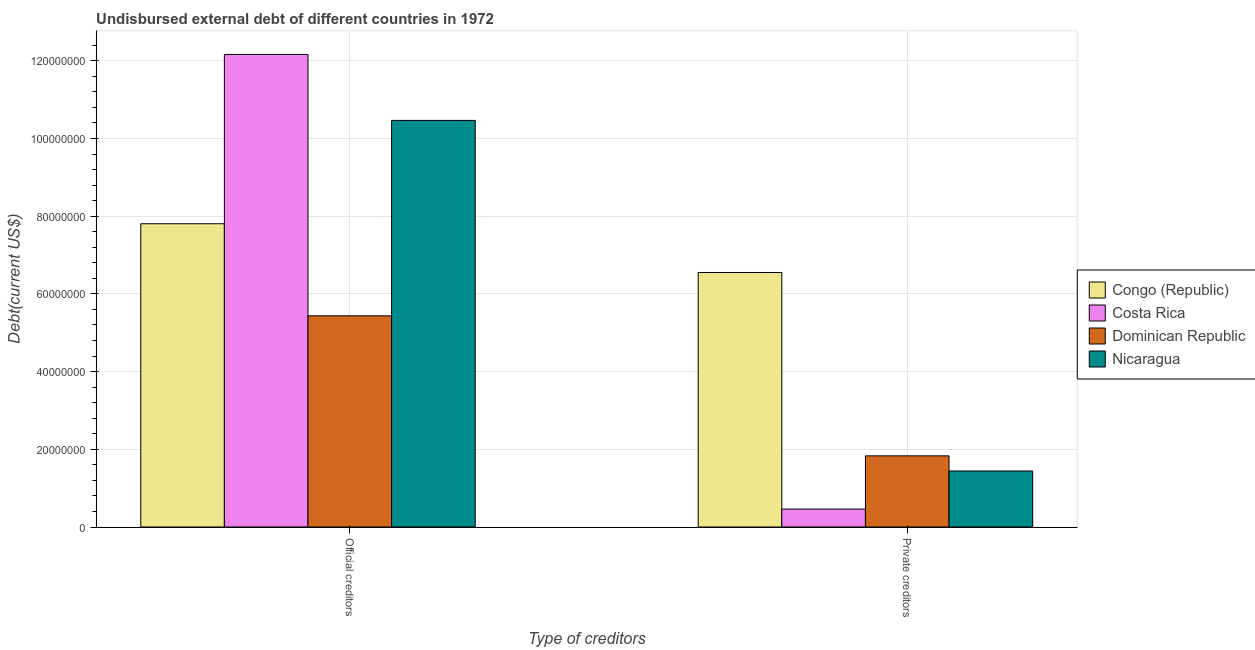How many different coloured bars are there?
Give a very brief answer. 4. How many groups of bars are there?
Make the answer very short. 2. How many bars are there on the 1st tick from the right?
Your answer should be compact. 4. What is the label of the 1st group of bars from the left?
Offer a very short reply. Official creditors. What is the undisbursed external debt of official creditors in Dominican Republic?
Offer a terse response. 5.44e+07. Across all countries, what is the maximum undisbursed external debt of official creditors?
Give a very brief answer. 1.22e+08. Across all countries, what is the minimum undisbursed external debt of private creditors?
Ensure brevity in your answer.  4.62e+06. What is the total undisbursed external debt of official creditors in the graph?
Offer a very short reply. 3.59e+08. What is the difference between the undisbursed external debt of private creditors in Nicaragua and that in Costa Rica?
Provide a succinct answer. 9.80e+06. What is the difference between the undisbursed external debt of official creditors in Costa Rica and the undisbursed external debt of private creditors in Congo (Republic)?
Your response must be concise. 5.61e+07. What is the average undisbursed external debt of official creditors per country?
Ensure brevity in your answer.  8.97e+07. What is the difference between the undisbursed external debt of official creditors and undisbursed external debt of private creditors in Costa Rica?
Your answer should be compact. 1.17e+08. In how many countries, is the undisbursed external debt of official creditors greater than 88000000 US$?
Provide a short and direct response. 2. What is the ratio of the undisbursed external debt of official creditors in Costa Rica to that in Nicaragua?
Provide a short and direct response. 1.16. What does the 1st bar from the left in Official creditors represents?
Make the answer very short. Congo (Republic). What does the 3rd bar from the right in Private creditors represents?
Your answer should be compact. Costa Rica. How many bars are there?
Your response must be concise. 8. Are all the bars in the graph horizontal?
Make the answer very short. No. How many countries are there in the graph?
Give a very brief answer. 4. Does the graph contain any zero values?
Your answer should be very brief. No. Does the graph contain grids?
Provide a succinct answer. Yes. How many legend labels are there?
Give a very brief answer. 4. What is the title of the graph?
Your response must be concise. Undisbursed external debt of different countries in 1972. Does "Greece" appear as one of the legend labels in the graph?
Make the answer very short. No. What is the label or title of the X-axis?
Offer a very short reply. Type of creditors. What is the label or title of the Y-axis?
Give a very brief answer. Debt(current US$). What is the Debt(current US$) of Congo (Republic) in Official creditors?
Provide a short and direct response. 7.81e+07. What is the Debt(current US$) in Costa Rica in Official creditors?
Make the answer very short. 1.22e+08. What is the Debt(current US$) of Dominican Republic in Official creditors?
Provide a succinct answer. 5.44e+07. What is the Debt(current US$) in Nicaragua in Official creditors?
Your response must be concise. 1.05e+08. What is the Debt(current US$) in Congo (Republic) in Private creditors?
Make the answer very short. 6.55e+07. What is the Debt(current US$) of Costa Rica in Private creditors?
Keep it short and to the point. 4.62e+06. What is the Debt(current US$) of Dominican Republic in Private creditors?
Make the answer very short. 1.83e+07. What is the Debt(current US$) in Nicaragua in Private creditors?
Give a very brief answer. 1.44e+07. Across all Type of creditors, what is the maximum Debt(current US$) in Congo (Republic)?
Provide a short and direct response. 7.81e+07. Across all Type of creditors, what is the maximum Debt(current US$) in Costa Rica?
Ensure brevity in your answer.  1.22e+08. Across all Type of creditors, what is the maximum Debt(current US$) in Dominican Republic?
Offer a very short reply. 5.44e+07. Across all Type of creditors, what is the maximum Debt(current US$) of Nicaragua?
Your answer should be very brief. 1.05e+08. Across all Type of creditors, what is the minimum Debt(current US$) of Congo (Republic)?
Give a very brief answer. 6.55e+07. Across all Type of creditors, what is the minimum Debt(current US$) in Costa Rica?
Ensure brevity in your answer.  4.62e+06. Across all Type of creditors, what is the minimum Debt(current US$) in Dominican Republic?
Offer a terse response. 1.83e+07. Across all Type of creditors, what is the minimum Debt(current US$) of Nicaragua?
Give a very brief answer. 1.44e+07. What is the total Debt(current US$) in Congo (Republic) in the graph?
Offer a very short reply. 1.44e+08. What is the total Debt(current US$) in Costa Rica in the graph?
Offer a very short reply. 1.26e+08. What is the total Debt(current US$) of Dominican Republic in the graph?
Your answer should be compact. 7.27e+07. What is the total Debt(current US$) of Nicaragua in the graph?
Offer a terse response. 1.19e+08. What is the difference between the Debt(current US$) of Congo (Republic) in Official creditors and that in Private creditors?
Ensure brevity in your answer.  1.25e+07. What is the difference between the Debt(current US$) in Costa Rica in Official creditors and that in Private creditors?
Ensure brevity in your answer.  1.17e+08. What is the difference between the Debt(current US$) in Dominican Republic in Official creditors and that in Private creditors?
Make the answer very short. 3.60e+07. What is the difference between the Debt(current US$) in Nicaragua in Official creditors and that in Private creditors?
Your answer should be very brief. 9.02e+07. What is the difference between the Debt(current US$) in Congo (Republic) in Official creditors and the Debt(current US$) in Costa Rica in Private creditors?
Offer a terse response. 7.34e+07. What is the difference between the Debt(current US$) in Congo (Republic) in Official creditors and the Debt(current US$) in Dominican Republic in Private creditors?
Ensure brevity in your answer.  5.97e+07. What is the difference between the Debt(current US$) of Congo (Republic) in Official creditors and the Debt(current US$) of Nicaragua in Private creditors?
Your answer should be compact. 6.36e+07. What is the difference between the Debt(current US$) of Costa Rica in Official creditors and the Debt(current US$) of Dominican Republic in Private creditors?
Make the answer very short. 1.03e+08. What is the difference between the Debt(current US$) of Costa Rica in Official creditors and the Debt(current US$) of Nicaragua in Private creditors?
Your answer should be very brief. 1.07e+08. What is the difference between the Debt(current US$) of Dominican Republic in Official creditors and the Debt(current US$) of Nicaragua in Private creditors?
Offer a very short reply. 3.99e+07. What is the average Debt(current US$) of Congo (Republic) per Type of creditors?
Your answer should be compact. 7.18e+07. What is the average Debt(current US$) of Costa Rica per Type of creditors?
Keep it short and to the point. 6.31e+07. What is the average Debt(current US$) in Dominican Republic per Type of creditors?
Offer a very short reply. 3.63e+07. What is the average Debt(current US$) of Nicaragua per Type of creditors?
Give a very brief answer. 5.95e+07. What is the difference between the Debt(current US$) of Congo (Republic) and Debt(current US$) of Costa Rica in Official creditors?
Your response must be concise. -4.36e+07. What is the difference between the Debt(current US$) of Congo (Republic) and Debt(current US$) of Dominican Republic in Official creditors?
Ensure brevity in your answer.  2.37e+07. What is the difference between the Debt(current US$) in Congo (Republic) and Debt(current US$) in Nicaragua in Official creditors?
Keep it short and to the point. -2.66e+07. What is the difference between the Debt(current US$) in Costa Rica and Debt(current US$) in Dominican Republic in Official creditors?
Your response must be concise. 6.73e+07. What is the difference between the Debt(current US$) of Costa Rica and Debt(current US$) of Nicaragua in Official creditors?
Offer a terse response. 1.70e+07. What is the difference between the Debt(current US$) in Dominican Republic and Debt(current US$) in Nicaragua in Official creditors?
Provide a short and direct response. -5.03e+07. What is the difference between the Debt(current US$) of Congo (Republic) and Debt(current US$) of Costa Rica in Private creditors?
Make the answer very short. 6.09e+07. What is the difference between the Debt(current US$) in Congo (Republic) and Debt(current US$) in Dominican Republic in Private creditors?
Your answer should be very brief. 4.72e+07. What is the difference between the Debt(current US$) in Congo (Republic) and Debt(current US$) in Nicaragua in Private creditors?
Offer a terse response. 5.11e+07. What is the difference between the Debt(current US$) in Costa Rica and Debt(current US$) in Dominican Republic in Private creditors?
Your answer should be very brief. -1.37e+07. What is the difference between the Debt(current US$) in Costa Rica and Debt(current US$) in Nicaragua in Private creditors?
Your response must be concise. -9.80e+06. What is the difference between the Debt(current US$) of Dominican Republic and Debt(current US$) of Nicaragua in Private creditors?
Offer a terse response. 3.90e+06. What is the ratio of the Debt(current US$) in Congo (Republic) in Official creditors to that in Private creditors?
Make the answer very short. 1.19. What is the ratio of the Debt(current US$) of Costa Rica in Official creditors to that in Private creditors?
Your answer should be compact. 26.35. What is the ratio of the Debt(current US$) in Dominican Republic in Official creditors to that in Private creditors?
Your answer should be compact. 2.97. What is the ratio of the Debt(current US$) of Nicaragua in Official creditors to that in Private creditors?
Your answer should be very brief. 7.26. What is the difference between the highest and the second highest Debt(current US$) in Congo (Republic)?
Keep it short and to the point. 1.25e+07. What is the difference between the highest and the second highest Debt(current US$) in Costa Rica?
Keep it short and to the point. 1.17e+08. What is the difference between the highest and the second highest Debt(current US$) of Dominican Republic?
Give a very brief answer. 3.60e+07. What is the difference between the highest and the second highest Debt(current US$) of Nicaragua?
Offer a terse response. 9.02e+07. What is the difference between the highest and the lowest Debt(current US$) in Congo (Republic)?
Keep it short and to the point. 1.25e+07. What is the difference between the highest and the lowest Debt(current US$) in Costa Rica?
Your response must be concise. 1.17e+08. What is the difference between the highest and the lowest Debt(current US$) of Dominican Republic?
Make the answer very short. 3.60e+07. What is the difference between the highest and the lowest Debt(current US$) of Nicaragua?
Your answer should be very brief. 9.02e+07. 